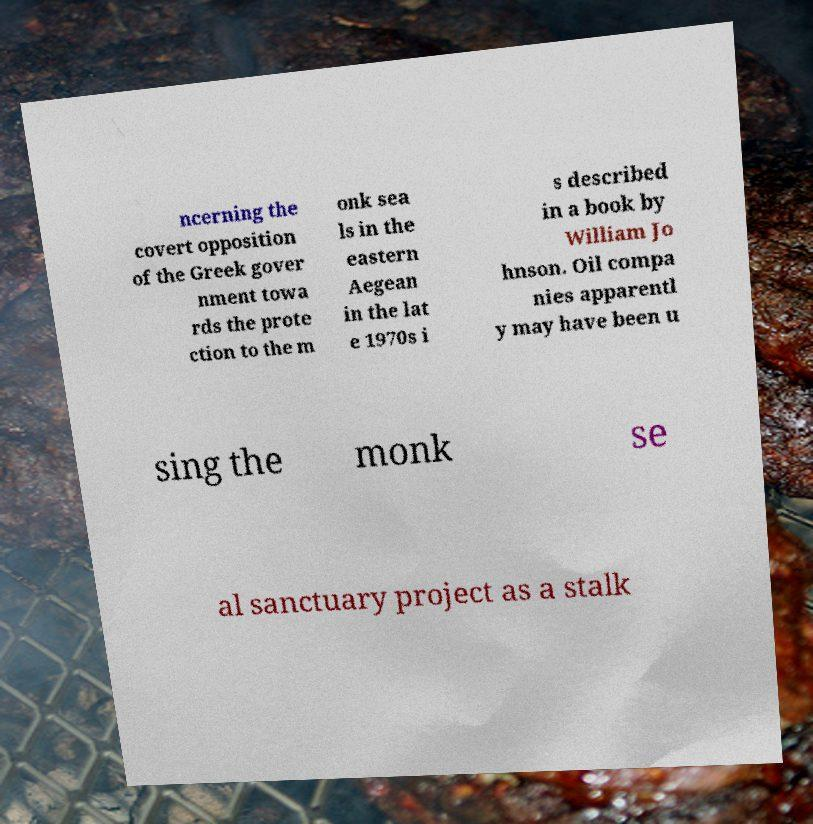Could you extract and type out the text from this image? ncerning the covert opposition of the Greek gover nment towa rds the prote ction to the m onk sea ls in the eastern Aegean in the lat e 1970s i s described in a book by William Jo hnson. Oil compa nies apparentl y may have been u sing the monk se al sanctuary project as a stalk 